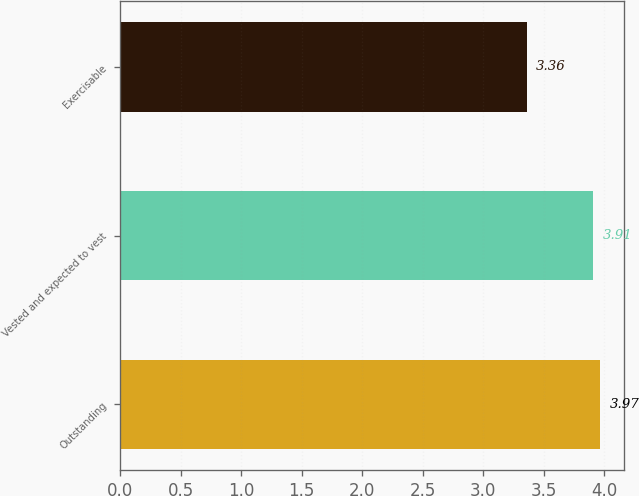Convert chart to OTSL. <chart><loc_0><loc_0><loc_500><loc_500><bar_chart><fcel>Outstanding<fcel>Vested and expected to vest<fcel>Exercisable<nl><fcel>3.97<fcel>3.91<fcel>3.36<nl></chart> 